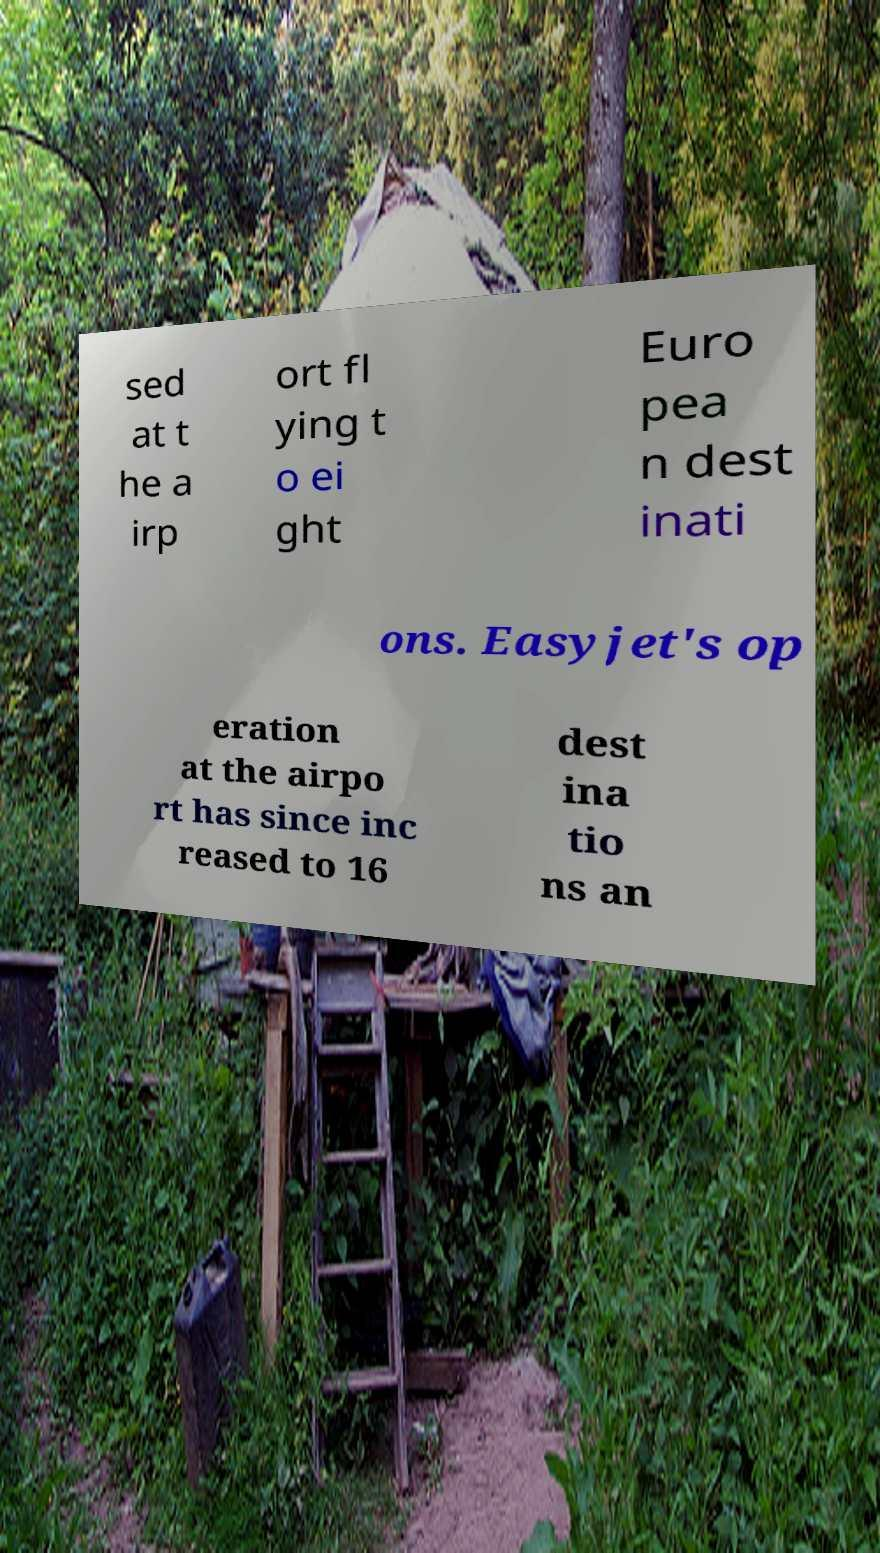Could you assist in decoding the text presented in this image and type it out clearly? sed at t he a irp ort fl ying t o ei ght Euro pea n dest inati ons. Easyjet's op eration at the airpo rt has since inc reased to 16 dest ina tio ns an 